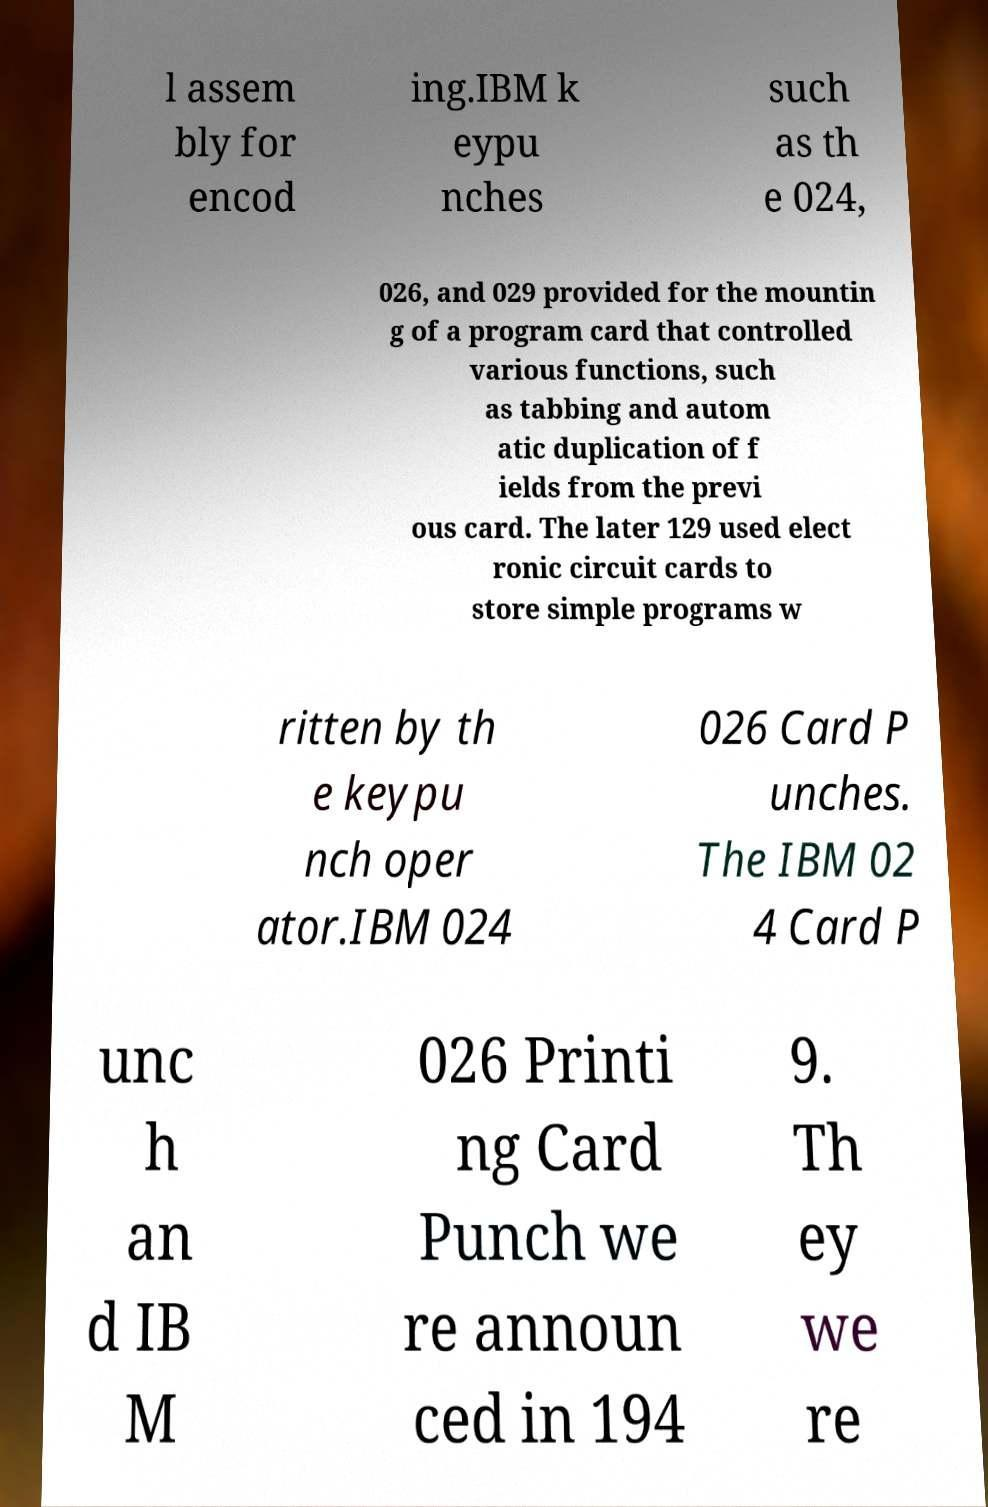I need the written content from this picture converted into text. Can you do that? l assem bly for encod ing.IBM k eypu nches such as th e 024, 026, and 029 provided for the mountin g of a program card that controlled various functions, such as tabbing and autom atic duplication of f ields from the previ ous card. The later 129 used elect ronic circuit cards to store simple programs w ritten by th e keypu nch oper ator.IBM 024 026 Card P unches. The IBM 02 4 Card P unc h an d IB M 026 Printi ng Card Punch we re announ ced in 194 9. Th ey we re 